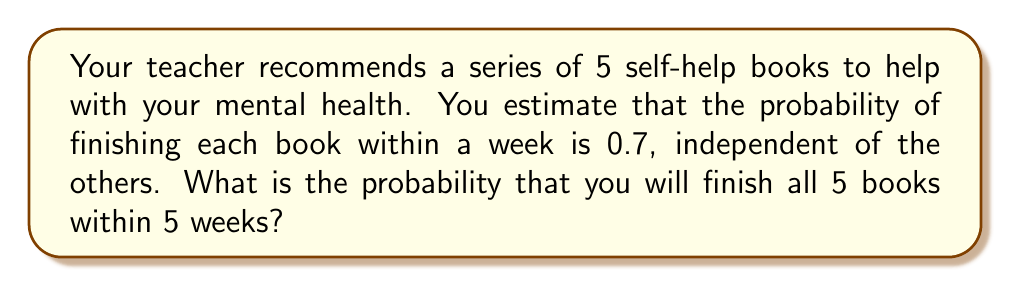Solve this math problem. Let's approach this step-by-step:

1) First, we need to recognize that this is a problem involving independent events. The probability of finishing each book is independent of the others.

2) We want the probability of finishing ALL 5 books. In probability terms, this means we're looking for the probability of 5 successes in 5 trials.

3) When we want all events to occur, and they're independent, we multiply the individual probabilities.

4) The probability of finishing each book is 0.7.

5) Therefore, the probability of finishing all 5 books is:

   $$ P(\text{all 5 books}) = 0.7 \times 0.7 \times 0.7 \times 0.7 \times 0.7 $$

6) This can be written as:

   $$ P(\text{all 5 books}) = (0.7)^5 $$

7) Now, let's calculate this:

   $$ (0.7)^5 = 0.16807 $$

8) Converting to a percentage:

   $$ 0.16807 \times 100\% = 16.807\% $$

Therefore, the probability of finishing all 5 books within 5 weeks is approximately 16.81%.
Answer: $16.81\%$ 